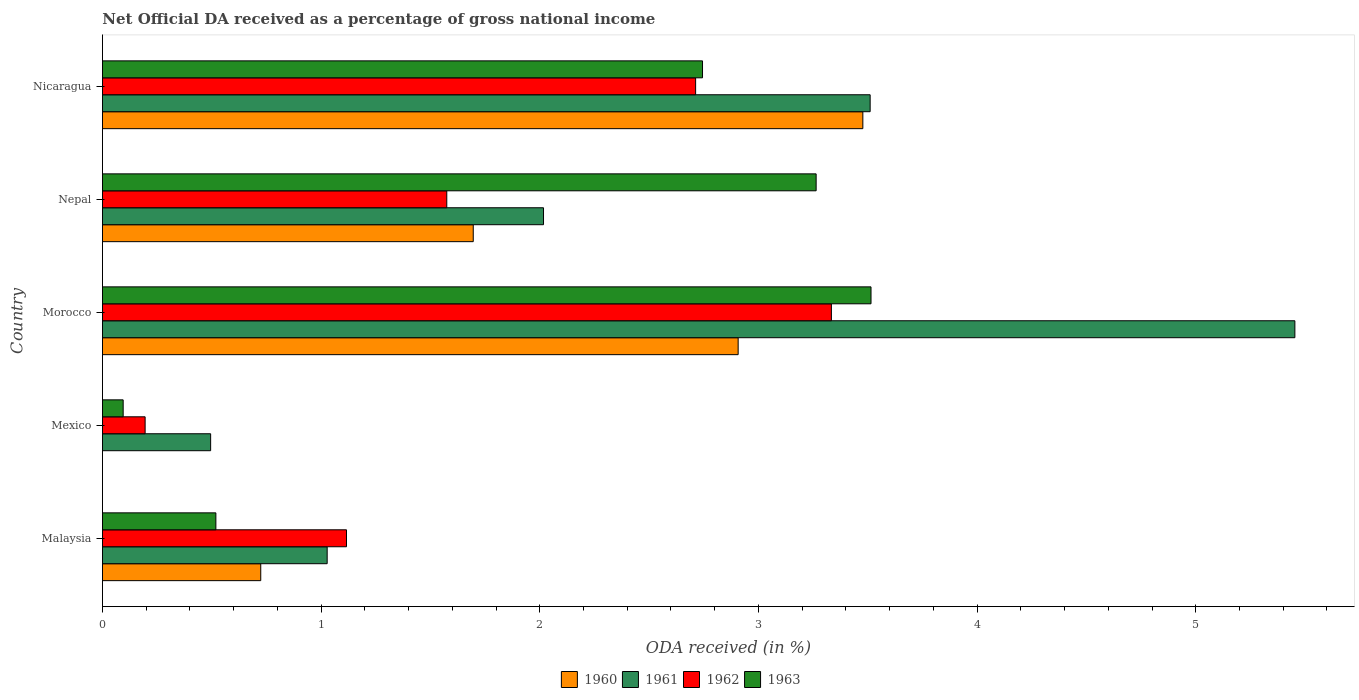How many groups of bars are there?
Your answer should be compact. 5. Are the number of bars on each tick of the Y-axis equal?
Provide a succinct answer. No. What is the label of the 2nd group of bars from the top?
Your answer should be compact. Nepal. What is the net official DA received in 1960 in Nepal?
Offer a terse response. 1.7. Across all countries, what is the maximum net official DA received in 1960?
Provide a succinct answer. 3.48. Across all countries, what is the minimum net official DA received in 1963?
Your answer should be compact. 0.09. In which country was the net official DA received in 1962 maximum?
Provide a succinct answer. Morocco. What is the total net official DA received in 1960 in the graph?
Offer a very short reply. 8.8. What is the difference between the net official DA received in 1963 in Morocco and that in Nicaragua?
Keep it short and to the point. 0.77. What is the difference between the net official DA received in 1961 in Malaysia and the net official DA received in 1962 in Nepal?
Offer a very short reply. -0.55. What is the average net official DA received in 1960 per country?
Keep it short and to the point. 1.76. What is the difference between the net official DA received in 1962 and net official DA received in 1960 in Malaysia?
Your answer should be compact. 0.39. What is the ratio of the net official DA received in 1961 in Malaysia to that in Mexico?
Your response must be concise. 2.08. Is the net official DA received in 1963 in Morocco less than that in Nepal?
Keep it short and to the point. No. What is the difference between the highest and the second highest net official DA received in 1960?
Your answer should be very brief. 0.57. What is the difference between the highest and the lowest net official DA received in 1963?
Provide a short and direct response. 3.42. In how many countries, is the net official DA received in 1963 greater than the average net official DA received in 1963 taken over all countries?
Provide a short and direct response. 3. Is the sum of the net official DA received in 1961 in Mexico and Nepal greater than the maximum net official DA received in 1963 across all countries?
Ensure brevity in your answer.  No. Is it the case that in every country, the sum of the net official DA received in 1963 and net official DA received in 1960 is greater than the net official DA received in 1961?
Your answer should be compact. No. Are all the bars in the graph horizontal?
Provide a succinct answer. Yes. What is the difference between two consecutive major ticks on the X-axis?
Provide a succinct answer. 1. Are the values on the major ticks of X-axis written in scientific E-notation?
Make the answer very short. No. Where does the legend appear in the graph?
Make the answer very short. Bottom center. How many legend labels are there?
Ensure brevity in your answer.  4. What is the title of the graph?
Provide a succinct answer. Net Official DA received as a percentage of gross national income. What is the label or title of the X-axis?
Your answer should be very brief. ODA received (in %). What is the ODA received (in %) of 1960 in Malaysia?
Your answer should be compact. 0.72. What is the ODA received (in %) in 1961 in Malaysia?
Make the answer very short. 1.03. What is the ODA received (in %) of 1962 in Malaysia?
Your answer should be compact. 1.12. What is the ODA received (in %) in 1963 in Malaysia?
Give a very brief answer. 0.52. What is the ODA received (in %) in 1960 in Mexico?
Your answer should be compact. 0. What is the ODA received (in %) in 1961 in Mexico?
Offer a terse response. 0.49. What is the ODA received (in %) in 1962 in Mexico?
Offer a very short reply. 0.2. What is the ODA received (in %) in 1963 in Mexico?
Keep it short and to the point. 0.09. What is the ODA received (in %) of 1960 in Morocco?
Provide a succinct answer. 2.91. What is the ODA received (in %) in 1961 in Morocco?
Give a very brief answer. 5.45. What is the ODA received (in %) in 1962 in Morocco?
Make the answer very short. 3.33. What is the ODA received (in %) of 1963 in Morocco?
Ensure brevity in your answer.  3.51. What is the ODA received (in %) in 1960 in Nepal?
Make the answer very short. 1.7. What is the ODA received (in %) of 1961 in Nepal?
Make the answer very short. 2.02. What is the ODA received (in %) of 1962 in Nepal?
Your response must be concise. 1.57. What is the ODA received (in %) of 1963 in Nepal?
Ensure brevity in your answer.  3.26. What is the ODA received (in %) in 1960 in Nicaragua?
Your response must be concise. 3.48. What is the ODA received (in %) of 1961 in Nicaragua?
Your answer should be very brief. 3.51. What is the ODA received (in %) of 1962 in Nicaragua?
Provide a succinct answer. 2.71. What is the ODA received (in %) of 1963 in Nicaragua?
Keep it short and to the point. 2.74. Across all countries, what is the maximum ODA received (in %) in 1960?
Your answer should be very brief. 3.48. Across all countries, what is the maximum ODA received (in %) in 1961?
Your response must be concise. 5.45. Across all countries, what is the maximum ODA received (in %) in 1962?
Make the answer very short. 3.33. Across all countries, what is the maximum ODA received (in %) of 1963?
Your answer should be very brief. 3.51. Across all countries, what is the minimum ODA received (in %) of 1960?
Make the answer very short. 0. Across all countries, what is the minimum ODA received (in %) of 1961?
Provide a succinct answer. 0.49. Across all countries, what is the minimum ODA received (in %) in 1962?
Offer a very short reply. 0.2. Across all countries, what is the minimum ODA received (in %) of 1963?
Make the answer very short. 0.09. What is the total ODA received (in %) in 1960 in the graph?
Provide a succinct answer. 8.8. What is the total ODA received (in %) of 1961 in the graph?
Your response must be concise. 12.5. What is the total ODA received (in %) in 1962 in the graph?
Ensure brevity in your answer.  8.93. What is the total ODA received (in %) in 1963 in the graph?
Offer a terse response. 10.14. What is the difference between the ODA received (in %) in 1961 in Malaysia and that in Mexico?
Provide a short and direct response. 0.53. What is the difference between the ODA received (in %) of 1962 in Malaysia and that in Mexico?
Keep it short and to the point. 0.92. What is the difference between the ODA received (in %) in 1963 in Malaysia and that in Mexico?
Keep it short and to the point. 0.42. What is the difference between the ODA received (in %) of 1960 in Malaysia and that in Morocco?
Offer a terse response. -2.18. What is the difference between the ODA received (in %) in 1961 in Malaysia and that in Morocco?
Provide a short and direct response. -4.43. What is the difference between the ODA received (in %) of 1962 in Malaysia and that in Morocco?
Provide a succinct answer. -2.22. What is the difference between the ODA received (in %) in 1963 in Malaysia and that in Morocco?
Your response must be concise. -3. What is the difference between the ODA received (in %) of 1960 in Malaysia and that in Nepal?
Provide a short and direct response. -0.97. What is the difference between the ODA received (in %) in 1961 in Malaysia and that in Nepal?
Offer a very short reply. -0.99. What is the difference between the ODA received (in %) of 1962 in Malaysia and that in Nepal?
Your answer should be very brief. -0.46. What is the difference between the ODA received (in %) in 1963 in Malaysia and that in Nepal?
Provide a succinct answer. -2.75. What is the difference between the ODA received (in %) of 1960 in Malaysia and that in Nicaragua?
Make the answer very short. -2.75. What is the difference between the ODA received (in %) of 1961 in Malaysia and that in Nicaragua?
Offer a terse response. -2.48. What is the difference between the ODA received (in %) in 1962 in Malaysia and that in Nicaragua?
Keep it short and to the point. -1.6. What is the difference between the ODA received (in %) in 1963 in Malaysia and that in Nicaragua?
Your response must be concise. -2.23. What is the difference between the ODA received (in %) in 1961 in Mexico and that in Morocco?
Ensure brevity in your answer.  -4.96. What is the difference between the ODA received (in %) of 1962 in Mexico and that in Morocco?
Provide a succinct answer. -3.14. What is the difference between the ODA received (in %) in 1963 in Mexico and that in Morocco?
Provide a short and direct response. -3.42. What is the difference between the ODA received (in %) in 1961 in Mexico and that in Nepal?
Your answer should be very brief. -1.52. What is the difference between the ODA received (in %) in 1962 in Mexico and that in Nepal?
Offer a terse response. -1.38. What is the difference between the ODA received (in %) in 1963 in Mexico and that in Nepal?
Offer a terse response. -3.17. What is the difference between the ODA received (in %) of 1961 in Mexico and that in Nicaragua?
Offer a very short reply. -3.02. What is the difference between the ODA received (in %) of 1962 in Mexico and that in Nicaragua?
Your response must be concise. -2.52. What is the difference between the ODA received (in %) in 1963 in Mexico and that in Nicaragua?
Make the answer very short. -2.65. What is the difference between the ODA received (in %) in 1960 in Morocco and that in Nepal?
Offer a very short reply. 1.21. What is the difference between the ODA received (in %) in 1961 in Morocco and that in Nepal?
Keep it short and to the point. 3.44. What is the difference between the ODA received (in %) of 1962 in Morocco and that in Nepal?
Provide a short and direct response. 1.76. What is the difference between the ODA received (in %) of 1963 in Morocco and that in Nepal?
Provide a short and direct response. 0.25. What is the difference between the ODA received (in %) in 1960 in Morocco and that in Nicaragua?
Your answer should be very brief. -0.57. What is the difference between the ODA received (in %) in 1961 in Morocco and that in Nicaragua?
Make the answer very short. 1.94. What is the difference between the ODA received (in %) of 1962 in Morocco and that in Nicaragua?
Give a very brief answer. 0.62. What is the difference between the ODA received (in %) in 1963 in Morocco and that in Nicaragua?
Your answer should be very brief. 0.77. What is the difference between the ODA received (in %) of 1960 in Nepal and that in Nicaragua?
Your answer should be compact. -1.78. What is the difference between the ODA received (in %) of 1961 in Nepal and that in Nicaragua?
Keep it short and to the point. -1.49. What is the difference between the ODA received (in %) of 1962 in Nepal and that in Nicaragua?
Your response must be concise. -1.14. What is the difference between the ODA received (in %) in 1963 in Nepal and that in Nicaragua?
Your response must be concise. 0.52. What is the difference between the ODA received (in %) of 1960 in Malaysia and the ODA received (in %) of 1961 in Mexico?
Your response must be concise. 0.23. What is the difference between the ODA received (in %) of 1960 in Malaysia and the ODA received (in %) of 1962 in Mexico?
Your answer should be very brief. 0.53. What is the difference between the ODA received (in %) in 1960 in Malaysia and the ODA received (in %) in 1963 in Mexico?
Offer a very short reply. 0.63. What is the difference between the ODA received (in %) of 1961 in Malaysia and the ODA received (in %) of 1962 in Mexico?
Give a very brief answer. 0.83. What is the difference between the ODA received (in %) in 1961 in Malaysia and the ODA received (in %) in 1963 in Mexico?
Provide a short and direct response. 0.93. What is the difference between the ODA received (in %) in 1962 in Malaysia and the ODA received (in %) in 1963 in Mexico?
Provide a short and direct response. 1.02. What is the difference between the ODA received (in %) in 1960 in Malaysia and the ODA received (in %) in 1961 in Morocco?
Provide a succinct answer. -4.73. What is the difference between the ODA received (in %) in 1960 in Malaysia and the ODA received (in %) in 1962 in Morocco?
Keep it short and to the point. -2.61. What is the difference between the ODA received (in %) in 1960 in Malaysia and the ODA received (in %) in 1963 in Morocco?
Make the answer very short. -2.79. What is the difference between the ODA received (in %) of 1961 in Malaysia and the ODA received (in %) of 1962 in Morocco?
Provide a succinct answer. -2.31. What is the difference between the ODA received (in %) of 1961 in Malaysia and the ODA received (in %) of 1963 in Morocco?
Ensure brevity in your answer.  -2.49. What is the difference between the ODA received (in %) in 1962 in Malaysia and the ODA received (in %) in 1963 in Morocco?
Keep it short and to the point. -2.4. What is the difference between the ODA received (in %) of 1960 in Malaysia and the ODA received (in %) of 1961 in Nepal?
Make the answer very short. -1.29. What is the difference between the ODA received (in %) of 1960 in Malaysia and the ODA received (in %) of 1962 in Nepal?
Your response must be concise. -0.85. What is the difference between the ODA received (in %) in 1960 in Malaysia and the ODA received (in %) in 1963 in Nepal?
Ensure brevity in your answer.  -2.54. What is the difference between the ODA received (in %) of 1961 in Malaysia and the ODA received (in %) of 1962 in Nepal?
Keep it short and to the point. -0.55. What is the difference between the ODA received (in %) in 1961 in Malaysia and the ODA received (in %) in 1963 in Nepal?
Provide a short and direct response. -2.24. What is the difference between the ODA received (in %) of 1962 in Malaysia and the ODA received (in %) of 1963 in Nepal?
Give a very brief answer. -2.15. What is the difference between the ODA received (in %) of 1960 in Malaysia and the ODA received (in %) of 1961 in Nicaragua?
Your answer should be very brief. -2.79. What is the difference between the ODA received (in %) in 1960 in Malaysia and the ODA received (in %) in 1962 in Nicaragua?
Give a very brief answer. -1.99. What is the difference between the ODA received (in %) of 1960 in Malaysia and the ODA received (in %) of 1963 in Nicaragua?
Provide a short and direct response. -2.02. What is the difference between the ODA received (in %) of 1961 in Malaysia and the ODA received (in %) of 1962 in Nicaragua?
Ensure brevity in your answer.  -1.69. What is the difference between the ODA received (in %) in 1961 in Malaysia and the ODA received (in %) in 1963 in Nicaragua?
Ensure brevity in your answer.  -1.72. What is the difference between the ODA received (in %) of 1962 in Malaysia and the ODA received (in %) of 1963 in Nicaragua?
Make the answer very short. -1.63. What is the difference between the ODA received (in %) in 1961 in Mexico and the ODA received (in %) in 1962 in Morocco?
Give a very brief answer. -2.84. What is the difference between the ODA received (in %) of 1961 in Mexico and the ODA received (in %) of 1963 in Morocco?
Provide a short and direct response. -3.02. What is the difference between the ODA received (in %) in 1962 in Mexico and the ODA received (in %) in 1963 in Morocco?
Provide a succinct answer. -3.32. What is the difference between the ODA received (in %) of 1961 in Mexico and the ODA received (in %) of 1962 in Nepal?
Provide a short and direct response. -1.08. What is the difference between the ODA received (in %) in 1961 in Mexico and the ODA received (in %) in 1963 in Nepal?
Give a very brief answer. -2.77. What is the difference between the ODA received (in %) of 1962 in Mexico and the ODA received (in %) of 1963 in Nepal?
Ensure brevity in your answer.  -3.07. What is the difference between the ODA received (in %) of 1961 in Mexico and the ODA received (in %) of 1962 in Nicaragua?
Keep it short and to the point. -2.22. What is the difference between the ODA received (in %) in 1961 in Mexico and the ODA received (in %) in 1963 in Nicaragua?
Provide a succinct answer. -2.25. What is the difference between the ODA received (in %) in 1962 in Mexico and the ODA received (in %) in 1963 in Nicaragua?
Your answer should be compact. -2.55. What is the difference between the ODA received (in %) of 1960 in Morocco and the ODA received (in %) of 1961 in Nepal?
Ensure brevity in your answer.  0.89. What is the difference between the ODA received (in %) of 1960 in Morocco and the ODA received (in %) of 1962 in Nepal?
Provide a short and direct response. 1.33. What is the difference between the ODA received (in %) of 1960 in Morocco and the ODA received (in %) of 1963 in Nepal?
Your response must be concise. -0.36. What is the difference between the ODA received (in %) of 1961 in Morocco and the ODA received (in %) of 1962 in Nepal?
Give a very brief answer. 3.88. What is the difference between the ODA received (in %) in 1961 in Morocco and the ODA received (in %) in 1963 in Nepal?
Provide a succinct answer. 2.19. What is the difference between the ODA received (in %) in 1962 in Morocco and the ODA received (in %) in 1963 in Nepal?
Make the answer very short. 0.07. What is the difference between the ODA received (in %) of 1960 in Morocco and the ODA received (in %) of 1961 in Nicaragua?
Offer a very short reply. -0.6. What is the difference between the ODA received (in %) in 1960 in Morocco and the ODA received (in %) in 1962 in Nicaragua?
Your answer should be very brief. 0.19. What is the difference between the ODA received (in %) of 1960 in Morocco and the ODA received (in %) of 1963 in Nicaragua?
Your response must be concise. 0.16. What is the difference between the ODA received (in %) of 1961 in Morocco and the ODA received (in %) of 1962 in Nicaragua?
Ensure brevity in your answer.  2.74. What is the difference between the ODA received (in %) in 1961 in Morocco and the ODA received (in %) in 1963 in Nicaragua?
Make the answer very short. 2.71. What is the difference between the ODA received (in %) in 1962 in Morocco and the ODA received (in %) in 1963 in Nicaragua?
Provide a succinct answer. 0.59. What is the difference between the ODA received (in %) of 1960 in Nepal and the ODA received (in %) of 1961 in Nicaragua?
Provide a succinct answer. -1.82. What is the difference between the ODA received (in %) in 1960 in Nepal and the ODA received (in %) in 1962 in Nicaragua?
Offer a terse response. -1.02. What is the difference between the ODA received (in %) in 1960 in Nepal and the ODA received (in %) in 1963 in Nicaragua?
Offer a terse response. -1.05. What is the difference between the ODA received (in %) in 1961 in Nepal and the ODA received (in %) in 1962 in Nicaragua?
Your response must be concise. -0.7. What is the difference between the ODA received (in %) of 1961 in Nepal and the ODA received (in %) of 1963 in Nicaragua?
Provide a short and direct response. -0.73. What is the difference between the ODA received (in %) in 1962 in Nepal and the ODA received (in %) in 1963 in Nicaragua?
Give a very brief answer. -1.17. What is the average ODA received (in %) of 1960 per country?
Make the answer very short. 1.76. What is the average ODA received (in %) of 1961 per country?
Keep it short and to the point. 2.5. What is the average ODA received (in %) of 1962 per country?
Make the answer very short. 1.79. What is the average ODA received (in %) in 1963 per country?
Make the answer very short. 2.03. What is the difference between the ODA received (in %) of 1960 and ODA received (in %) of 1961 in Malaysia?
Offer a very short reply. -0.3. What is the difference between the ODA received (in %) of 1960 and ODA received (in %) of 1962 in Malaysia?
Your answer should be very brief. -0.39. What is the difference between the ODA received (in %) in 1960 and ODA received (in %) in 1963 in Malaysia?
Keep it short and to the point. 0.21. What is the difference between the ODA received (in %) of 1961 and ODA received (in %) of 1962 in Malaysia?
Your answer should be very brief. -0.09. What is the difference between the ODA received (in %) of 1961 and ODA received (in %) of 1963 in Malaysia?
Give a very brief answer. 0.51. What is the difference between the ODA received (in %) in 1962 and ODA received (in %) in 1963 in Malaysia?
Keep it short and to the point. 0.6. What is the difference between the ODA received (in %) of 1961 and ODA received (in %) of 1962 in Mexico?
Provide a short and direct response. 0.3. What is the difference between the ODA received (in %) of 1962 and ODA received (in %) of 1963 in Mexico?
Give a very brief answer. 0.1. What is the difference between the ODA received (in %) in 1960 and ODA received (in %) in 1961 in Morocco?
Your response must be concise. -2.55. What is the difference between the ODA received (in %) of 1960 and ODA received (in %) of 1962 in Morocco?
Provide a short and direct response. -0.43. What is the difference between the ODA received (in %) in 1960 and ODA received (in %) in 1963 in Morocco?
Your answer should be very brief. -0.61. What is the difference between the ODA received (in %) in 1961 and ODA received (in %) in 1962 in Morocco?
Provide a succinct answer. 2.12. What is the difference between the ODA received (in %) in 1961 and ODA received (in %) in 1963 in Morocco?
Provide a succinct answer. 1.94. What is the difference between the ODA received (in %) of 1962 and ODA received (in %) of 1963 in Morocco?
Ensure brevity in your answer.  -0.18. What is the difference between the ODA received (in %) in 1960 and ODA received (in %) in 1961 in Nepal?
Keep it short and to the point. -0.32. What is the difference between the ODA received (in %) in 1960 and ODA received (in %) in 1962 in Nepal?
Your answer should be compact. 0.12. What is the difference between the ODA received (in %) of 1960 and ODA received (in %) of 1963 in Nepal?
Provide a short and direct response. -1.57. What is the difference between the ODA received (in %) in 1961 and ODA received (in %) in 1962 in Nepal?
Your answer should be compact. 0.44. What is the difference between the ODA received (in %) in 1961 and ODA received (in %) in 1963 in Nepal?
Make the answer very short. -1.25. What is the difference between the ODA received (in %) of 1962 and ODA received (in %) of 1963 in Nepal?
Offer a very short reply. -1.69. What is the difference between the ODA received (in %) in 1960 and ODA received (in %) in 1961 in Nicaragua?
Make the answer very short. -0.03. What is the difference between the ODA received (in %) of 1960 and ODA received (in %) of 1962 in Nicaragua?
Ensure brevity in your answer.  0.76. What is the difference between the ODA received (in %) of 1960 and ODA received (in %) of 1963 in Nicaragua?
Offer a terse response. 0.73. What is the difference between the ODA received (in %) of 1961 and ODA received (in %) of 1962 in Nicaragua?
Give a very brief answer. 0.8. What is the difference between the ODA received (in %) in 1961 and ODA received (in %) in 1963 in Nicaragua?
Offer a very short reply. 0.77. What is the difference between the ODA received (in %) of 1962 and ODA received (in %) of 1963 in Nicaragua?
Your answer should be very brief. -0.03. What is the ratio of the ODA received (in %) of 1961 in Malaysia to that in Mexico?
Provide a short and direct response. 2.08. What is the ratio of the ODA received (in %) of 1962 in Malaysia to that in Mexico?
Offer a very short reply. 5.72. What is the ratio of the ODA received (in %) in 1963 in Malaysia to that in Mexico?
Keep it short and to the point. 5.48. What is the ratio of the ODA received (in %) of 1960 in Malaysia to that in Morocco?
Make the answer very short. 0.25. What is the ratio of the ODA received (in %) of 1961 in Malaysia to that in Morocco?
Make the answer very short. 0.19. What is the ratio of the ODA received (in %) in 1962 in Malaysia to that in Morocco?
Keep it short and to the point. 0.33. What is the ratio of the ODA received (in %) of 1963 in Malaysia to that in Morocco?
Give a very brief answer. 0.15. What is the ratio of the ODA received (in %) of 1960 in Malaysia to that in Nepal?
Your response must be concise. 0.43. What is the ratio of the ODA received (in %) of 1961 in Malaysia to that in Nepal?
Offer a terse response. 0.51. What is the ratio of the ODA received (in %) of 1962 in Malaysia to that in Nepal?
Offer a very short reply. 0.71. What is the ratio of the ODA received (in %) in 1963 in Malaysia to that in Nepal?
Provide a short and direct response. 0.16. What is the ratio of the ODA received (in %) of 1960 in Malaysia to that in Nicaragua?
Provide a short and direct response. 0.21. What is the ratio of the ODA received (in %) of 1961 in Malaysia to that in Nicaragua?
Your answer should be very brief. 0.29. What is the ratio of the ODA received (in %) in 1962 in Malaysia to that in Nicaragua?
Keep it short and to the point. 0.41. What is the ratio of the ODA received (in %) in 1963 in Malaysia to that in Nicaragua?
Offer a very short reply. 0.19. What is the ratio of the ODA received (in %) in 1961 in Mexico to that in Morocco?
Your response must be concise. 0.09. What is the ratio of the ODA received (in %) in 1962 in Mexico to that in Morocco?
Make the answer very short. 0.06. What is the ratio of the ODA received (in %) in 1963 in Mexico to that in Morocco?
Ensure brevity in your answer.  0.03. What is the ratio of the ODA received (in %) in 1961 in Mexico to that in Nepal?
Your response must be concise. 0.25. What is the ratio of the ODA received (in %) in 1962 in Mexico to that in Nepal?
Give a very brief answer. 0.12. What is the ratio of the ODA received (in %) in 1963 in Mexico to that in Nepal?
Keep it short and to the point. 0.03. What is the ratio of the ODA received (in %) in 1961 in Mexico to that in Nicaragua?
Keep it short and to the point. 0.14. What is the ratio of the ODA received (in %) in 1962 in Mexico to that in Nicaragua?
Provide a short and direct response. 0.07. What is the ratio of the ODA received (in %) of 1963 in Mexico to that in Nicaragua?
Your answer should be very brief. 0.03. What is the ratio of the ODA received (in %) in 1960 in Morocco to that in Nepal?
Make the answer very short. 1.71. What is the ratio of the ODA received (in %) in 1961 in Morocco to that in Nepal?
Offer a terse response. 2.7. What is the ratio of the ODA received (in %) of 1962 in Morocco to that in Nepal?
Keep it short and to the point. 2.12. What is the ratio of the ODA received (in %) in 1963 in Morocco to that in Nepal?
Your response must be concise. 1.08. What is the ratio of the ODA received (in %) in 1960 in Morocco to that in Nicaragua?
Offer a terse response. 0.84. What is the ratio of the ODA received (in %) of 1961 in Morocco to that in Nicaragua?
Your answer should be very brief. 1.55. What is the ratio of the ODA received (in %) of 1962 in Morocco to that in Nicaragua?
Ensure brevity in your answer.  1.23. What is the ratio of the ODA received (in %) in 1963 in Morocco to that in Nicaragua?
Your response must be concise. 1.28. What is the ratio of the ODA received (in %) of 1960 in Nepal to that in Nicaragua?
Provide a short and direct response. 0.49. What is the ratio of the ODA received (in %) in 1961 in Nepal to that in Nicaragua?
Give a very brief answer. 0.57. What is the ratio of the ODA received (in %) of 1962 in Nepal to that in Nicaragua?
Provide a short and direct response. 0.58. What is the ratio of the ODA received (in %) in 1963 in Nepal to that in Nicaragua?
Provide a short and direct response. 1.19. What is the difference between the highest and the second highest ODA received (in %) of 1960?
Your response must be concise. 0.57. What is the difference between the highest and the second highest ODA received (in %) of 1961?
Ensure brevity in your answer.  1.94. What is the difference between the highest and the second highest ODA received (in %) in 1962?
Your answer should be compact. 0.62. What is the difference between the highest and the second highest ODA received (in %) in 1963?
Provide a short and direct response. 0.25. What is the difference between the highest and the lowest ODA received (in %) of 1960?
Provide a succinct answer. 3.48. What is the difference between the highest and the lowest ODA received (in %) in 1961?
Provide a succinct answer. 4.96. What is the difference between the highest and the lowest ODA received (in %) of 1962?
Provide a short and direct response. 3.14. What is the difference between the highest and the lowest ODA received (in %) in 1963?
Offer a terse response. 3.42. 